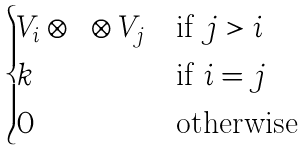Convert formula to latex. <formula><loc_0><loc_0><loc_500><loc_500>\begin{cases} V _ { i } \otimes \cdots \otimes V _ { j } & \text {if $j>i$} \\ k & \text {if $i=j$} \\ 0 & \text {otherwise} \end{cases}</formula> 